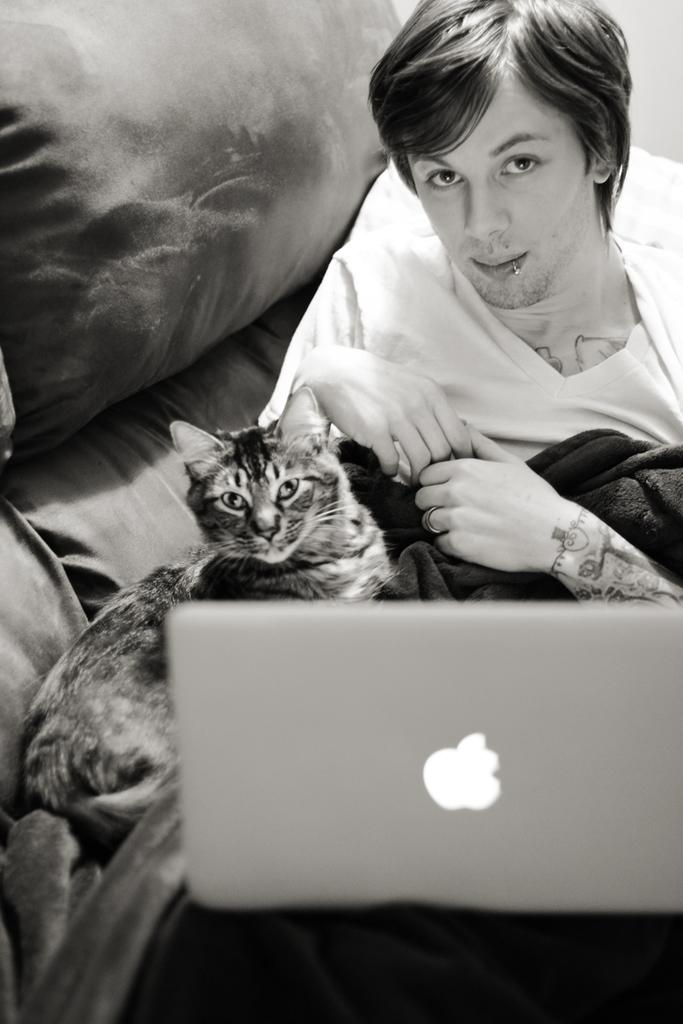What is the main subject of the image? The main subject of the image is a man. What is the man doing in the image? The man is leaning on the bed. What electronic device is on the bed? There is a laptop on the bed. What type of animal is on the bed? There is a cat on the bed. What type of bed accessory is present in the image? There are pillows on the bed. How many ladybugs are crawling on the laptop in the image? There are no ladybugs present in the image. What shape is the cat in the image? The cat is not a shape; it is a living animal. 